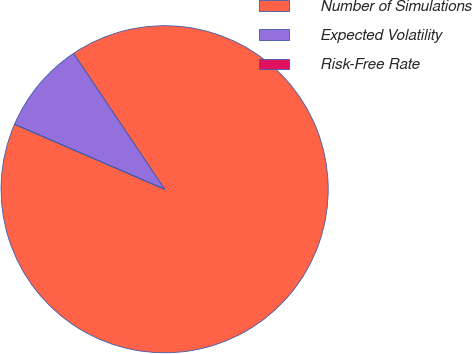Convert chart to OTSL. <chart><loc_0><loc_0><loc_500><loc_500><pie_chart><fcel>Number of Simulations<fcel>Expected Volatility<fcel>Risk-Free Rate<nl><fcel>90.91%<fcel>9.09%<fcel>0.0%<nl></chart> 